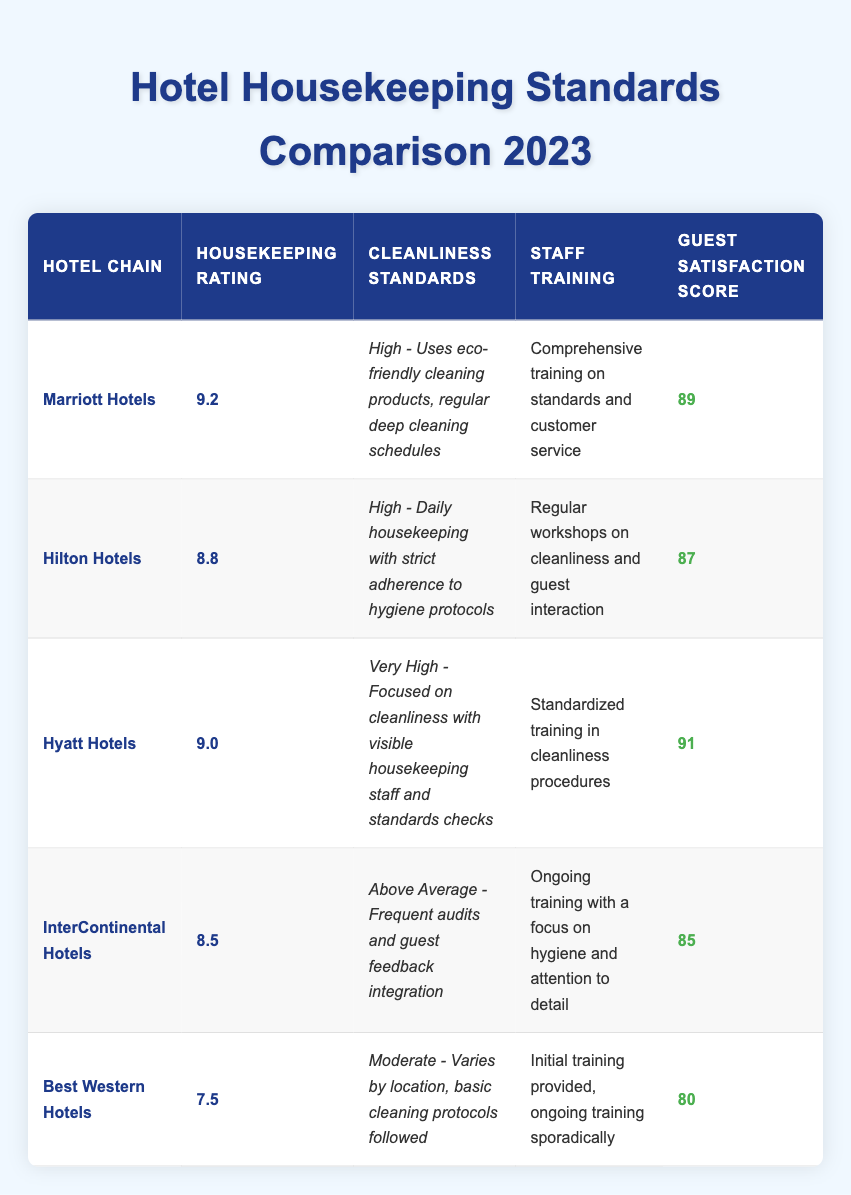What is the housekeeping rating of Hyatt Hotels? The table shows "Hyatt Hotels" in the hotel chain column, and its housekeeping rating is listed as "9.0".
Answer: 9.0 Which hotel chain has the highest guest satisfaction score? The guest satisfaction scores are 89 for Marriott, 87 for Hilton, 91 for Hyatt, 85 for InterContinental, and 80 for Best Western. Comparing these, Hyatt has the highest score of 91.
Answer: Hyatt Hotels What is the average housekeeping rating of all five hotel chains? The ratings are 9.2, 8.8, 9.0, 8.5, and 7.5. Adding them gives 9.2 + 8.8 + 9.0 + 8.5 + 7.5 = 43. The average is then 43 divided by 5, which equals 8.6.
Answer: 8.6 Do all hotel chains use eco-friendly cleaning products for their housekeeping? The table specifies that Marriott uses eco-friendly cleaning products, while Hilton, Hyatt, InterContinental, and Best Western do not mention this. Therefore, the statement is false.
Answer: No Which hotel chain has a cleanliness standard described as "Very High"? In the table, "Hyatt Hotels" is listed with the cleanliness standard "Very High - Focused on cleanliness with visible housekeeping staff and standards checks".
Answer: Hyatt Hotels Is there a hotel chain with a cleanliness standard that varies by location? The table indicates that "Best Western Hotels" has a cleanliness standard of "Moderate - Varies by location, basic cleaning protocols followed". Therefore, the answer is yes.
Answer: Yes What is the difference in guest satisfaction scores between Marriott Hotels and InterContinental Hotels? The guest satisfaction score for Marriott is 89, and for InterContinental it is 85. The difference is 89 - 85 = 4.
Answer: 4 Which hotel chain has comprehensive training on standards and customer service? According to the table, "Marriott Hotels" has "Comprehensive training on standards and customer service", making it the only chain with this specific training described.
Answer: Marriott Hotels How many hotel chains have a housekeeping rating above 8.5? The chains with ratings above 8.5 are Marriott (9.2), Hyatt (9.0), and Hilton (8.8). That totals three chains above 8.5.
Answer: 3 